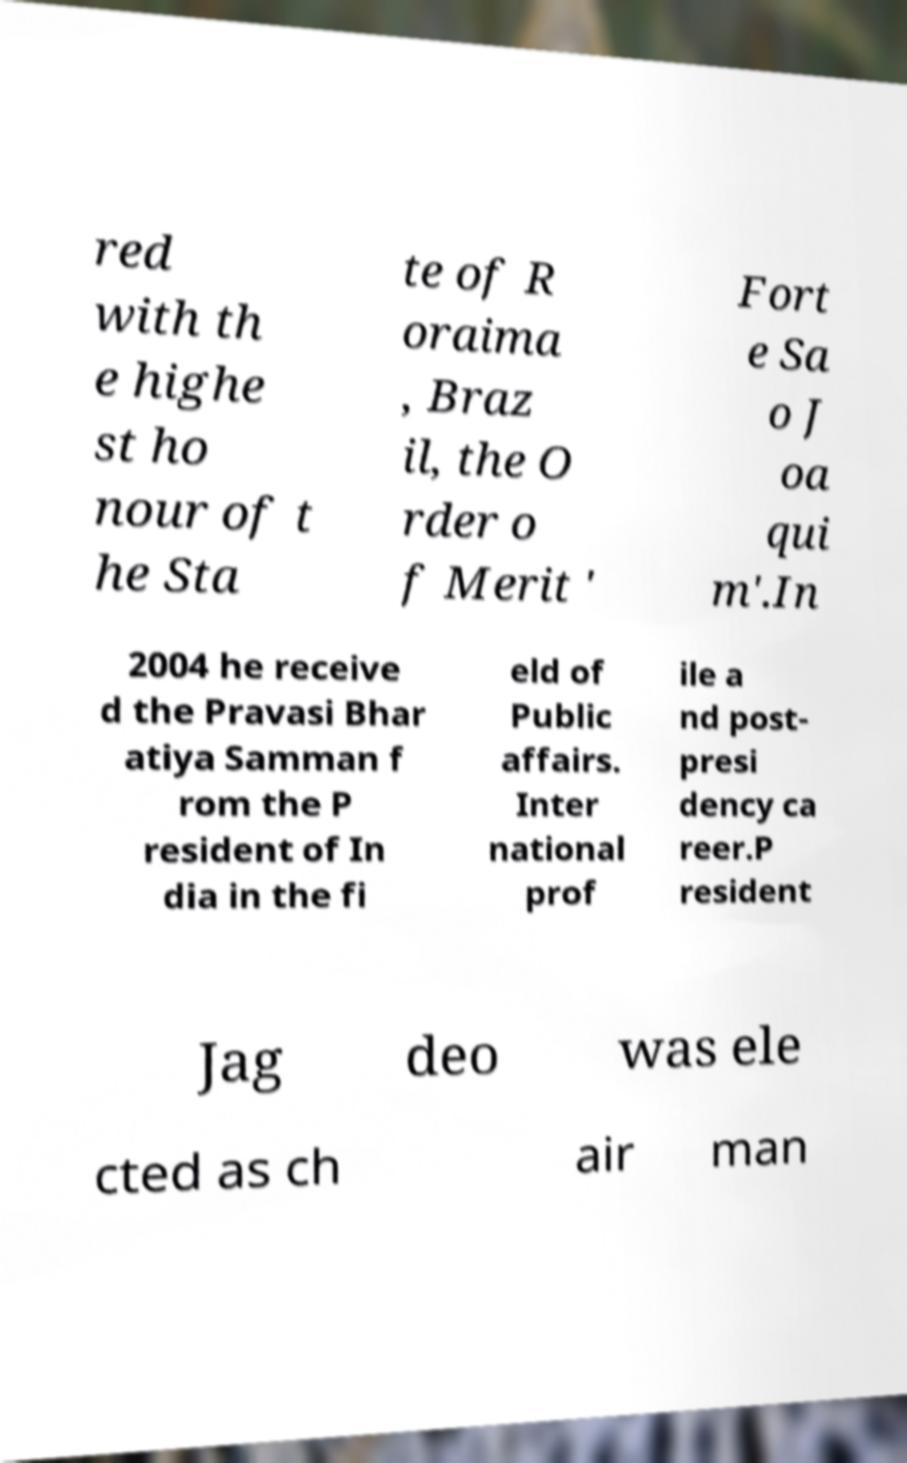Please read and relay the text visible in this image. What does it say? red with th e highe st ho nour of t he Sta te of R oraima , Braz il, the O rder o f Merit ' Fort e Sa o J oa qui m'.In 2004 he receive d the Pravasi Bhar atiya Samman f rom the P resident of In dia in the fi eld of Public affairs. Inter national prof ile a nd post- presi dency ca reer.P resident Jag deo was ele cted as ch air man 